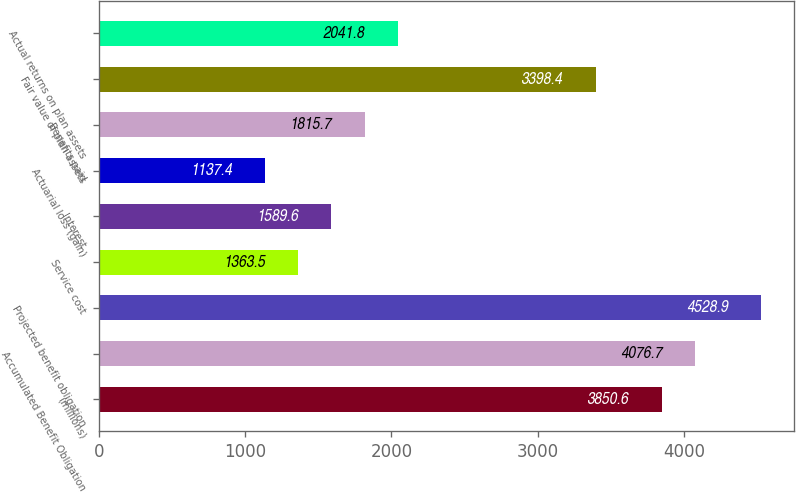<chart> <loc_0><loc_0><loc_500><loc_500><bar_chart><fcel>(millions)<fcel>Accumulated Benefit Obligation<fcel>Projected benefit obligation<fcel>Service cost<fcel>Interest<fcel>Actuarial loss (gain)<fcel>Benefits paid<fcel>Fair value of plan assets<fcel>Actual returns on plan assets<nl><fcel>3850.6<fcel>4076.7<fcel>4528.9<fcel>1363.5<fcel>1589.6<fcel>1137.4<fcel>1815.7<fcel>3398.4<fcel>2041.8<nl></chart> 